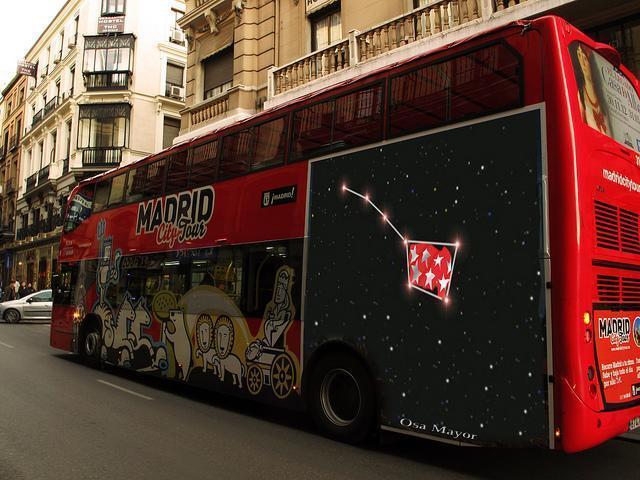How many floors in this bus?
Give a very brief answer. 2. How many yellow birds are in this picture?
Give a very brief answer. 0. 